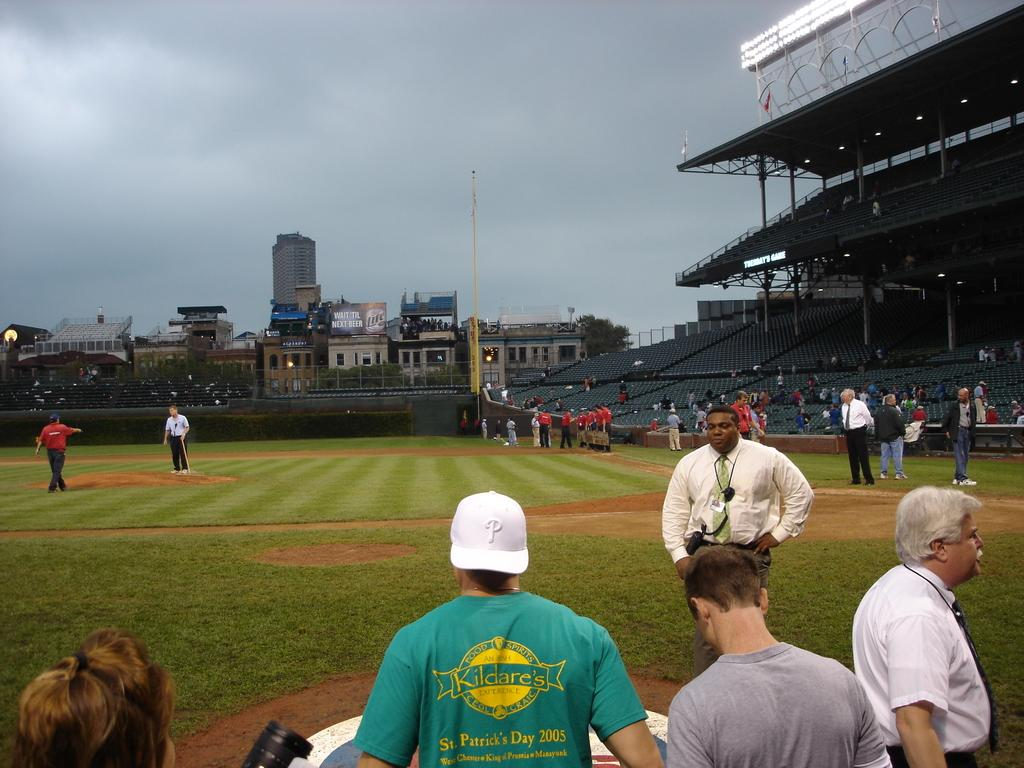<image>
Share a concise interpretation of the image provided. a baseball field with a Lite ad in the outfield area 